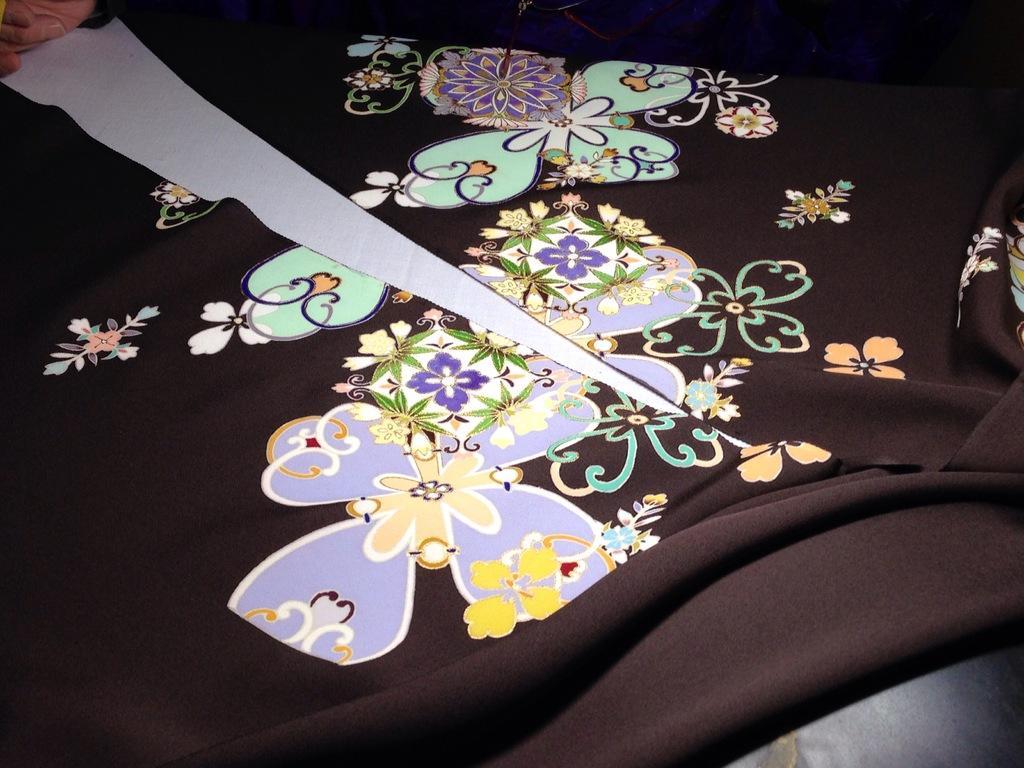Please provide a concise description of this image. In the picture we can see a black color cloth some designs on it and which as cut in the middle of the cloth. 